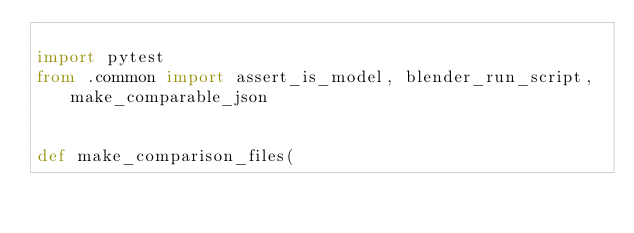Convert code to text. <code><loc_0><loc_0><loc_500><loc_500><_Python_>
import pytest
from .common import assert_is_model, blender_run_script, make_comparable_json


def make_comparison_files(</code> 